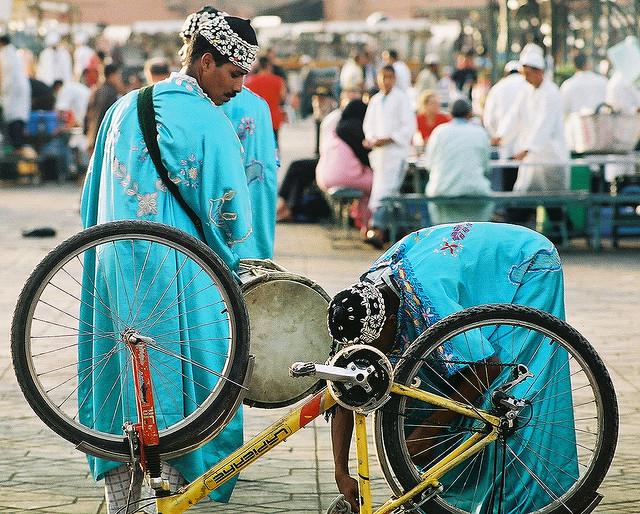What color are the robes?
Answer briefly. Blue. Does one often associate formal robes, such as these, with the upside down vehicle?
Quick response, please. No. What else is visible?
Keep it brief. Bike. 